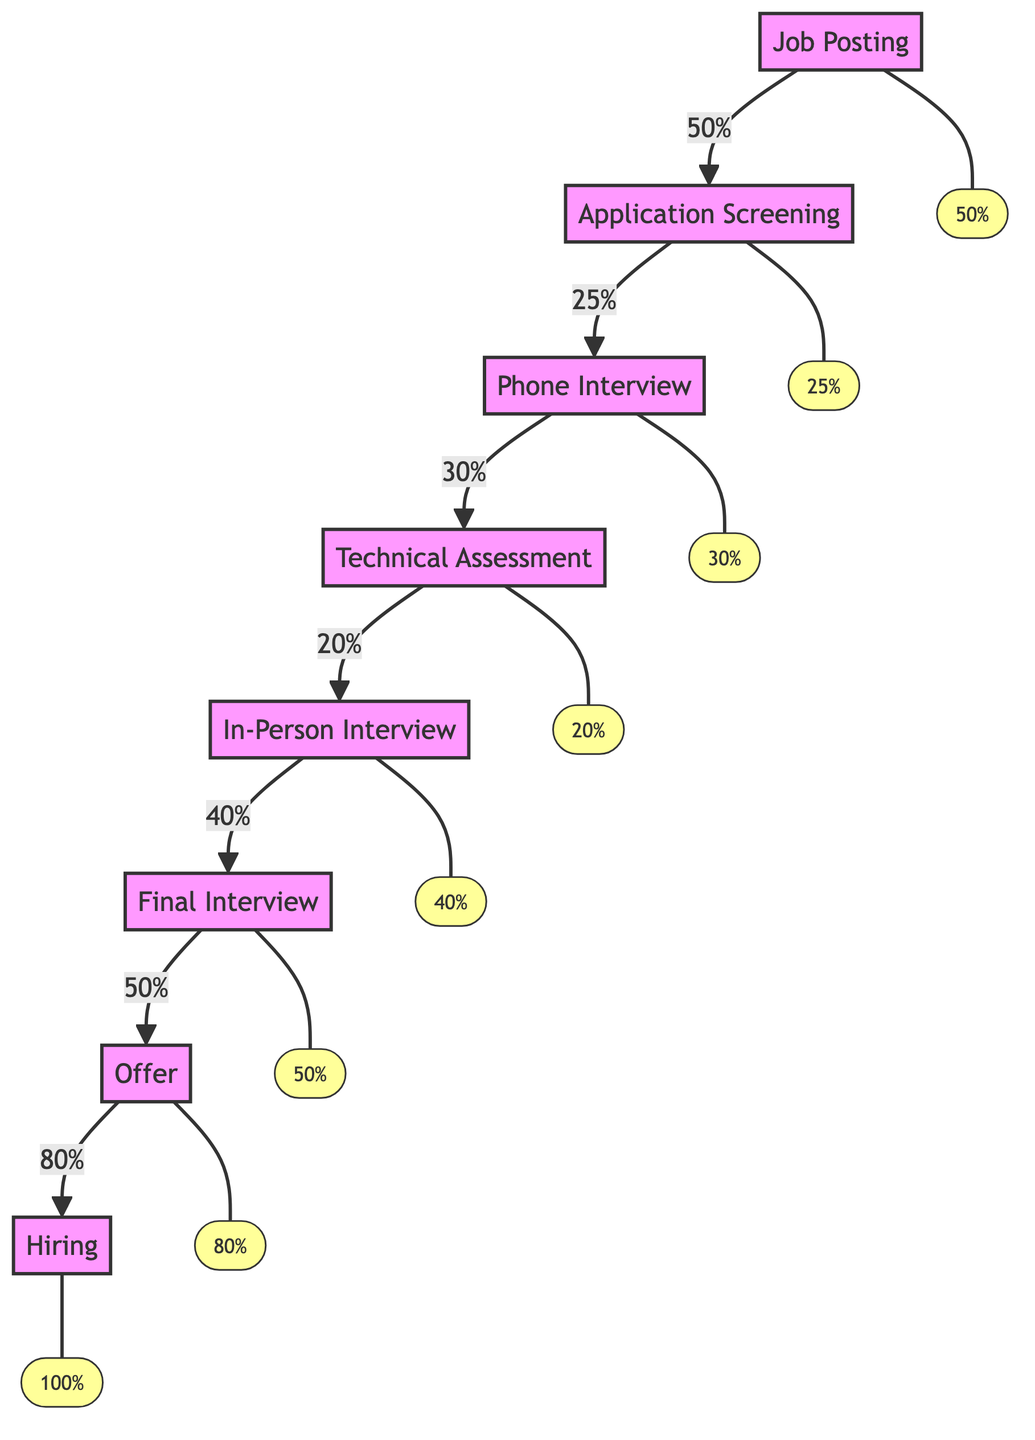What is the conversion rate from Job Posting to Application Screening? The conversion rate is indicated in the flow from the Job Posting node to the Application Screening node, which shows a value of 50% next to the arrow.
Answer: 50% What is the last stage before Hiring? The diagram shows that the last stage before Hiring is the Offer stage, as Hiring comes after Offer, connected by an arrow.
Answer: Offer How many stages are there in the recruitment funnel? By counting each labeled stage in the diagram, there are a total of eight stages listed from Job Posting to Hiring.
Answer: Eight What is the conversion rate for the Technical Assessment stage? The Technical Assessment node has an arrow that connects to it with a value of 20%, indicating its conversion rate shown next to the arrow.
Answer: 20% Which stage has the highest conversion rate? Looking through the conversion rates provided for each stage, the Offer stage shows the highest conversion rate at 80%.
Answer: 80% What is the conversion rate from In-Person Interview to Final Interview? The flow from In-Person Interview to Final Interview is indicated in the diagram with a value of 50% next to the arrow pointing towards Final Interview.
Answer: 50% What is the conversion rate from Phone Interview to Technical Assessment? The arrow from Phone Interview to Technical Assessment shows a conversion rate of 30%, which can be directly seen on the connecting arrow in the diagram.
Answer: 30% Which stage is the first in the recruitment funnel? The diagram clearly indicates Job Posting as the starting point of the recruitment funnel, as it is the first node listed in the flow.
Answer: Job Posting 